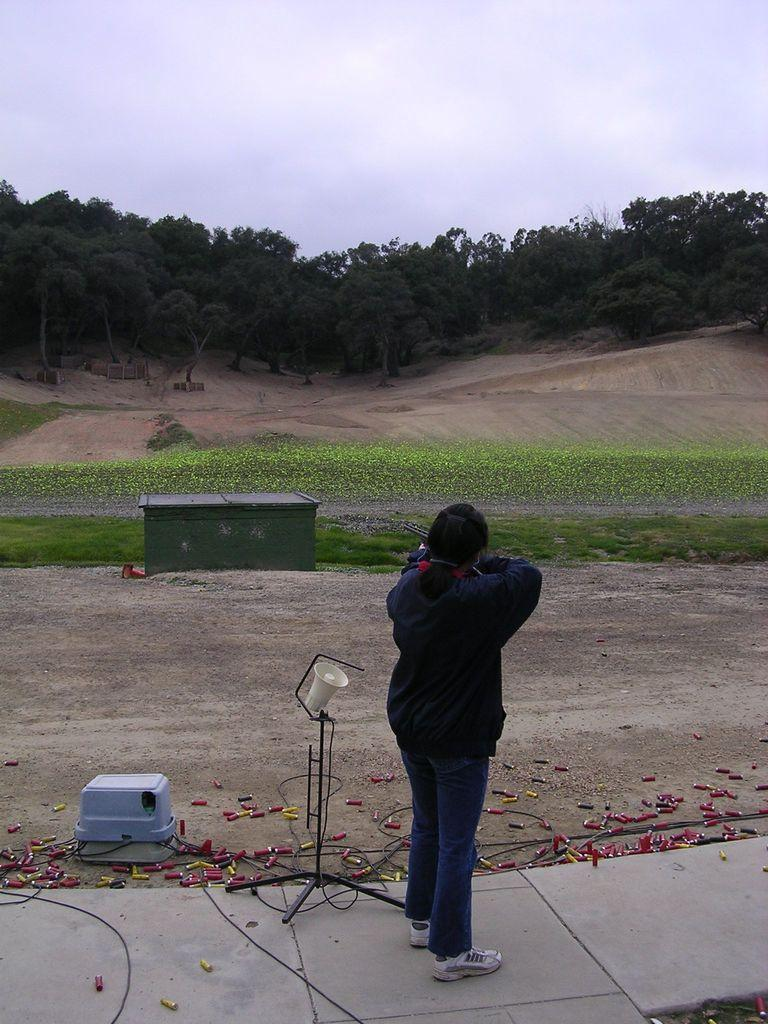What is the main subject of the image? There is a woman standing in the image. Where is the woman standing? The woman is standing on a path. What else can be seen in the image besides the woman? There is a stand, grass, trees, and the sky visible in the image. What is the condition of the sky in the image? The sky is visible in the background of the image, and clouds are present. What type of furniture is the woman using to begin cooking the stew in the image? There is no furniture, cooking, or stew present in the image. 